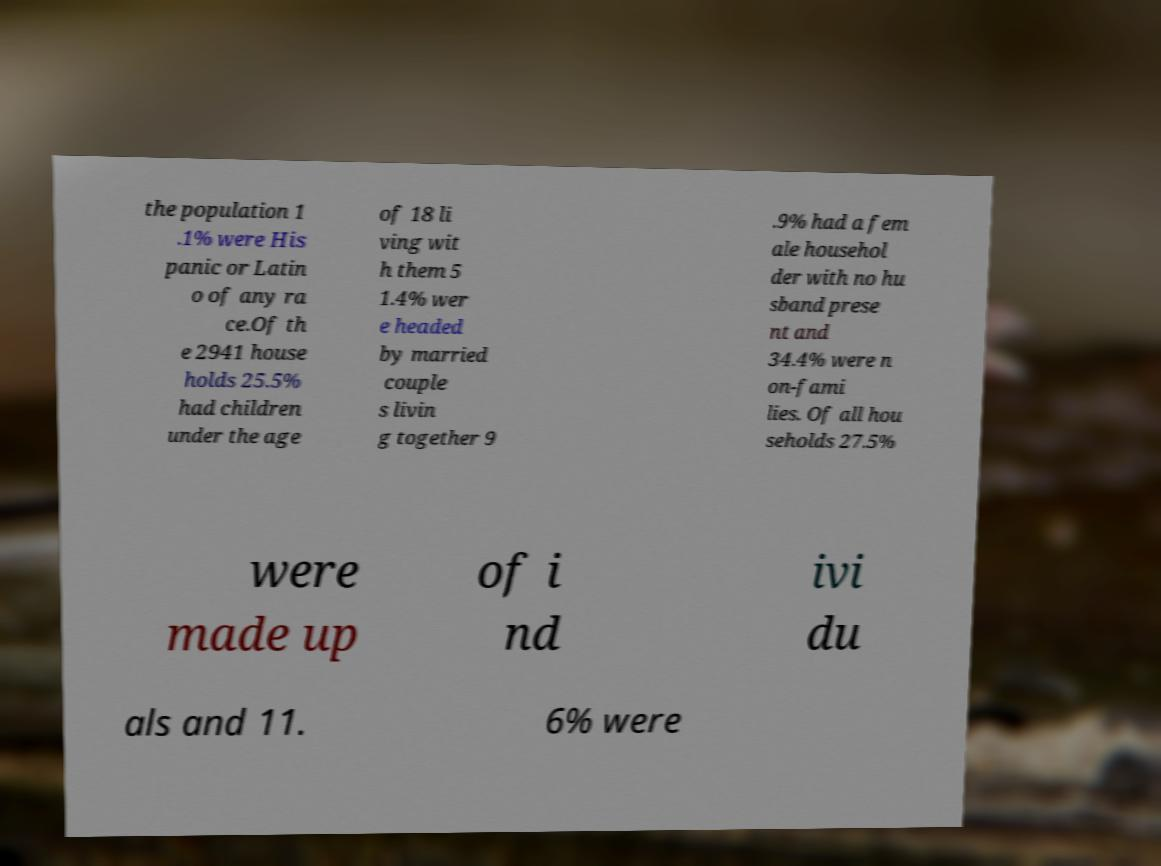I need the written content from this picture converted into text. Can you do that? the population 1 .1% were His panic or Latin o of any ra ce.Of th e 2941 house holds 25.5% had children under the age of 18 li ving wit h them 5 1.4% wer e headed by married couple s livin g together 9 .9% had a fem ale househol der with no hu sband prese nt and 34.4% were n on-fami lies. Of all hou seholds 27.5% were made up of i nd ivi du als and 11. 6% were 